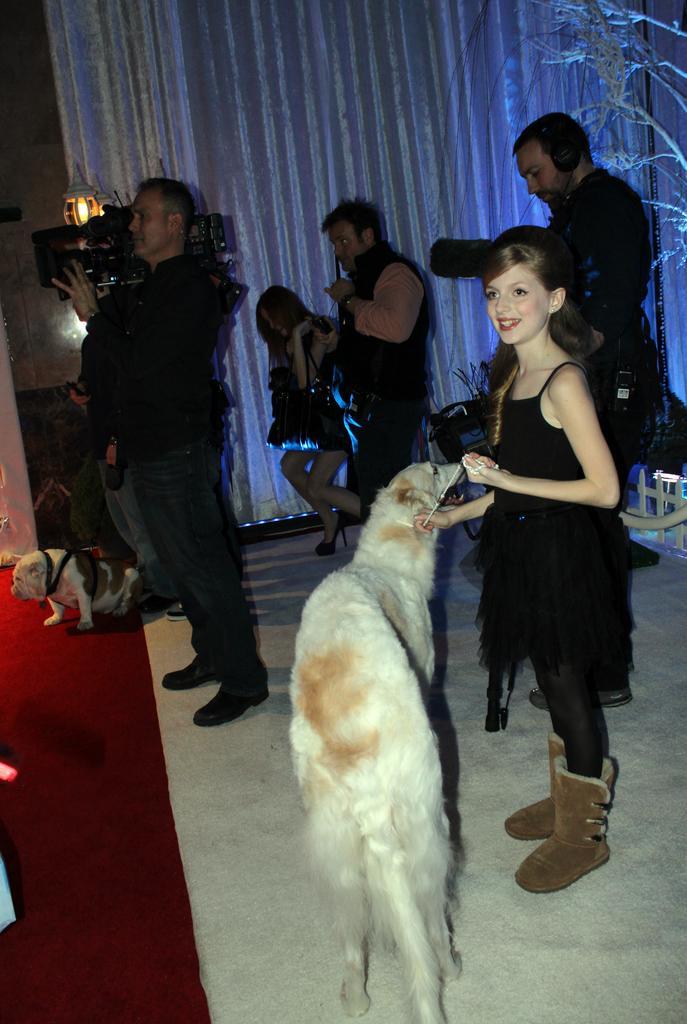In one or two sentences, can you explain what this image depicts? On the right hand side of the image, there is a girl standing and laughing. In front of her, there is a white color dog standing on the floor. In the background, there are two persons holding cameras, a person standing, a women, a white color curtain, wall, light, a dog, red color carpet and a person. 